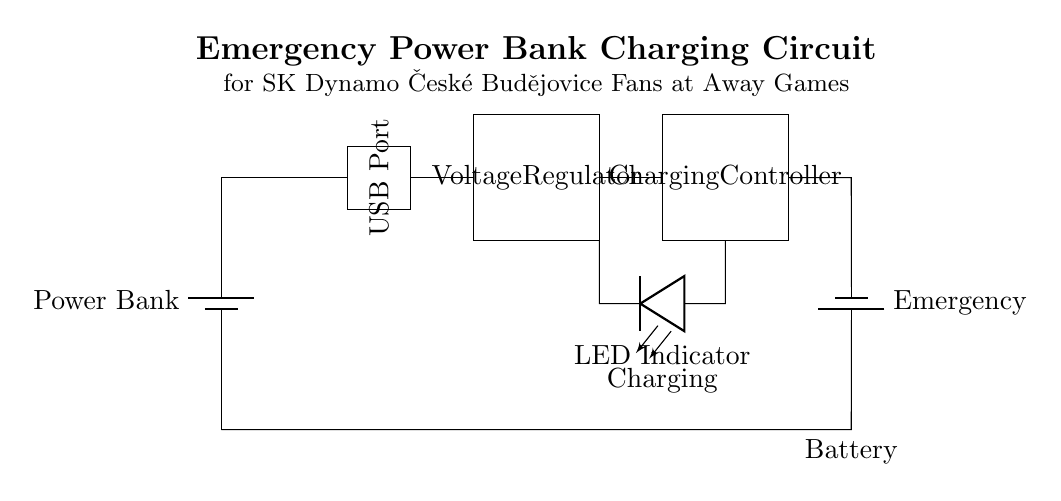What component is used to regulate voltage? The voltage regulator is the component that regulates the voltage in the circuit to ensure that the connected devices receive a stable voltage level, protecting them from fluctuations.
Answer: Voltage Regulator What indicates that the power bank is charging? The LED indicator is placed in the circuit to show that the charging process is active. When the power bank is connected and charging, this LED will light up, signaling the status of the charging.
Answer: Charging How many main components are in this circuit? The circuit includes five main components: the power bank, USB port, voltage regulator, charging controller, and emergency battery. Counting each of these gives the total number of main components.
Answer: Five What is the purpose of the charging controller? The charging controller manages the charging process by controlling the flow of current from the power bank to the battery, ensuring the battery is charged safely and efficiently without overcharging.
Answer: Charging Controller Which component provides power to the emergency battery? The power bank is the primary source that supplies power to the emergency battery through the voltage regulator and charging controller. It ensures that the battery can be charged when needed, especially during away games.
Answer: Power Bank 